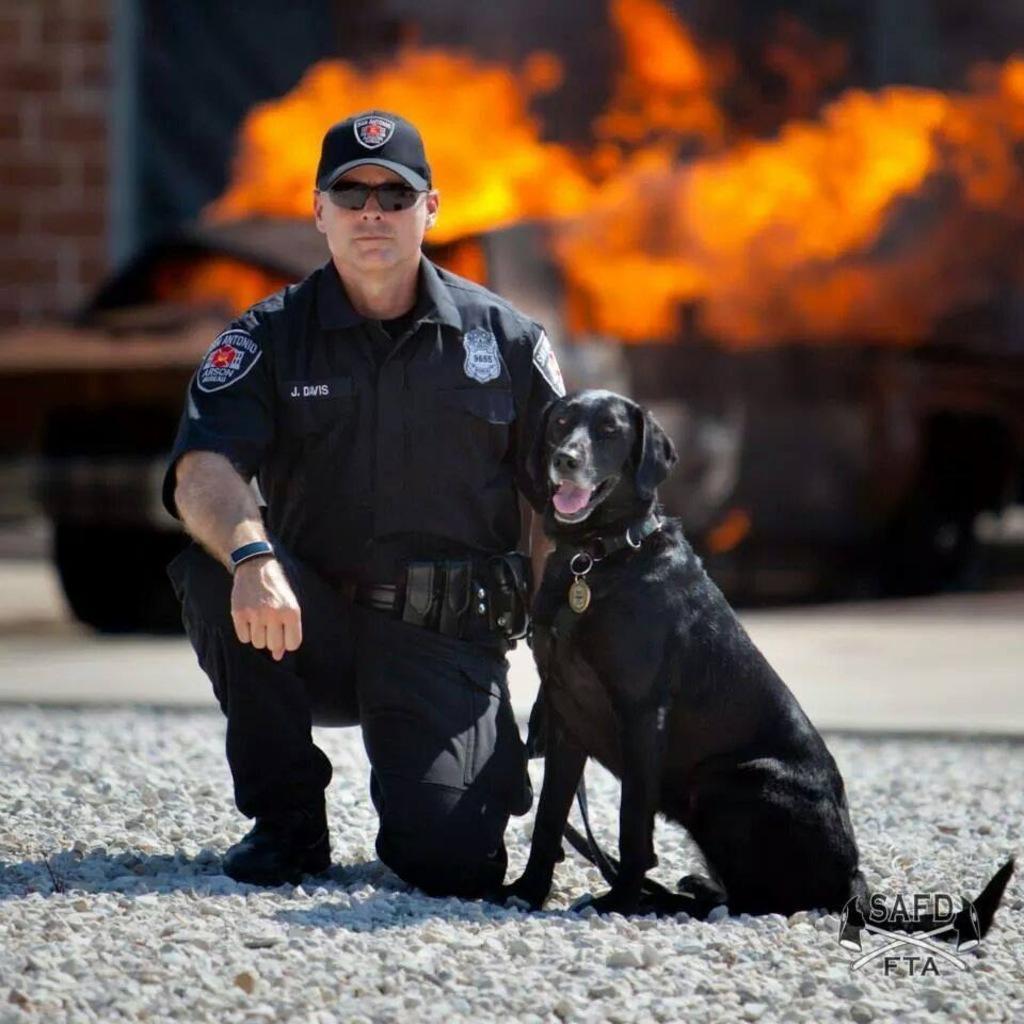How would you summarize this image in a sentence or two? In the middle of the image a man is sitting. Beside the man there is a dog. Behind them there is a flame. Top left side of the image there is a wall. 